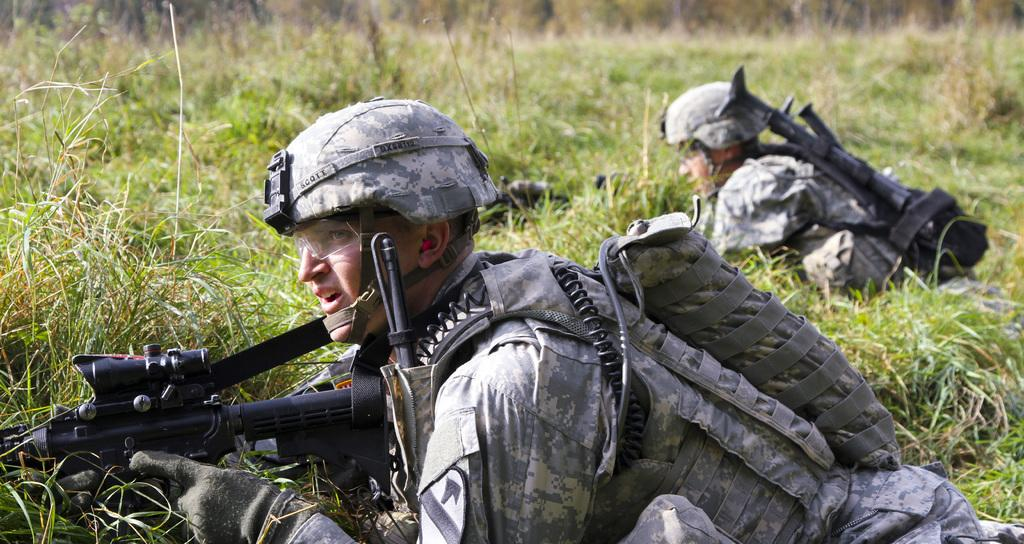What type of vegetation is present in the image? The image contains grass. What are the two persons in the image doing? The two persons are lying on the grass. What type of clothing are the persons wearing? The persons are wearing military dress. What type of headgear are the persons wearing? The persons are wearing caps. What objects are the persons holding in the image? The persons are holding guns. What type of cord is being used to tie the salt container in the image? There is no cord or salt container present in the image. 